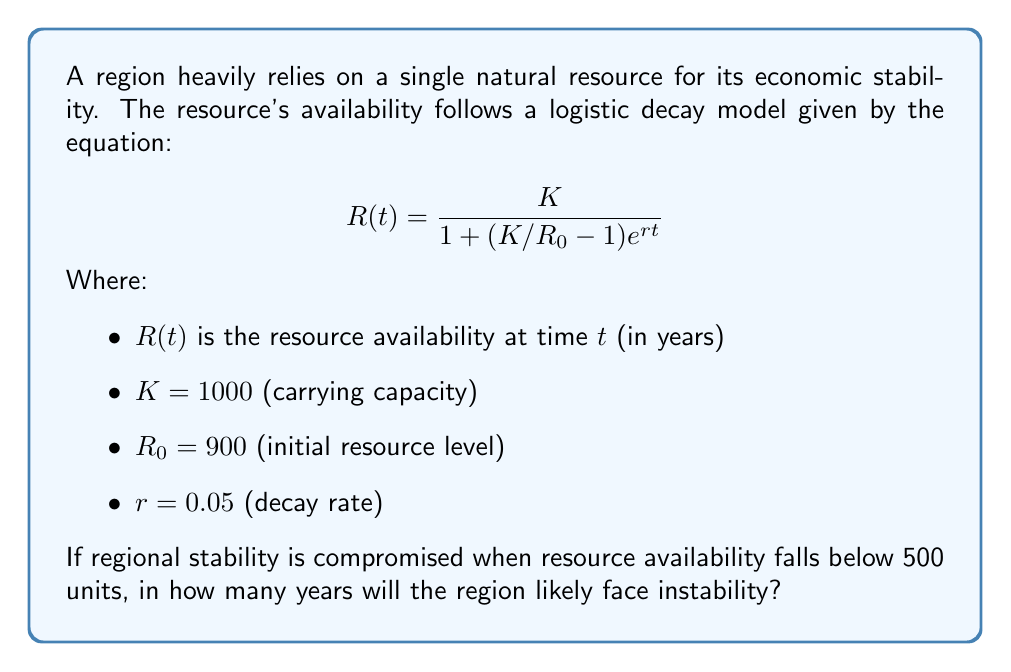Provide a solution to this math problem. To solve this problem, we need to find the time $t$ when $R(t) = 500$. Let's approach this step-by-step:

1) We start with the logistic decay equation:
   $$500 = \frac{1000}{1 + (1000/900 - 1)e^{0.05t}}$$

2) Simplify the fraction in the exponential:
   $$500 = \frac{1000}{1 + (10/9 - 1)e^{0.05t}} = \frac{1000}{1 + (1/9)e^{0.05t}}$$

3) Multiply both sides by the denominator:
   $$500(1 + (1/9)e^{0.05t}) = 1000$$

4) Distribute on the left side:
   $$500 + (500/9)e^{0.05t} = 1000$$

5) Subtract 500 from both sides:
   $$(500/9)e^{0.05t} = 500$$

6) Multiply both sides by 9/500:
   $$e^{0.05t} = 9$$

7) Take the natural log of both sides:
   $$0.05t = \ln(9)$$

8) Solve for $t$:
   $$t = \frac{\ln(9)}{0.05} \approx 44.36$$

Therefore, the region will likely face instability in approximately 44.36 years.
Answer: 44.36 years 